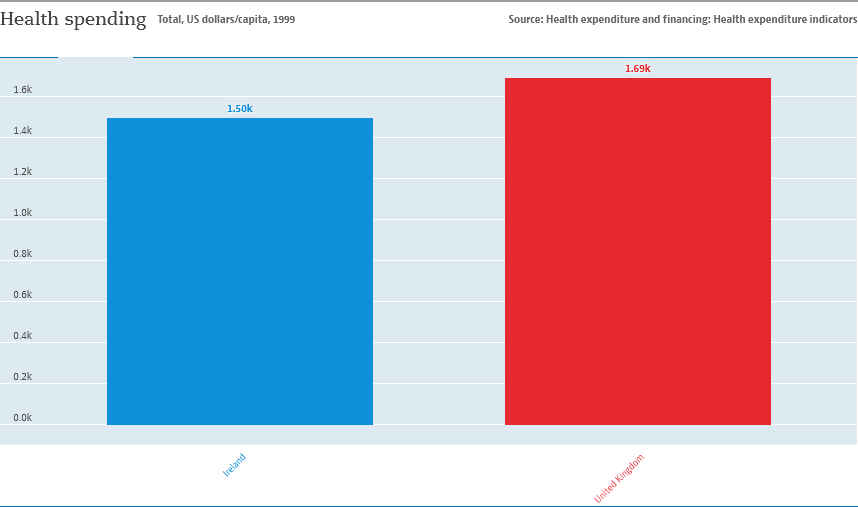Outline some significant characteristics in this image. The color of the largest bar is red. The difference in the value of both bars is 0.19. 